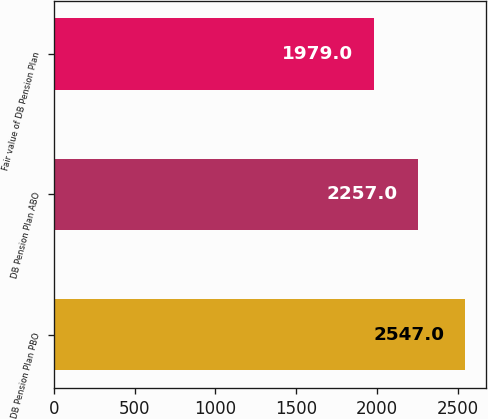<chart> <loc_0><loc_0><loc_500><loc_500><bar_chart><fcel>DB Pension Plan PBO<fcel>DB Pension Plan ABO<fcel>Fair value of DB Pension Plan<nl><fcel>2547<fcel>2257<fcel>1979<nl></chart> 